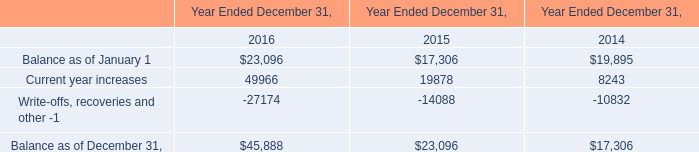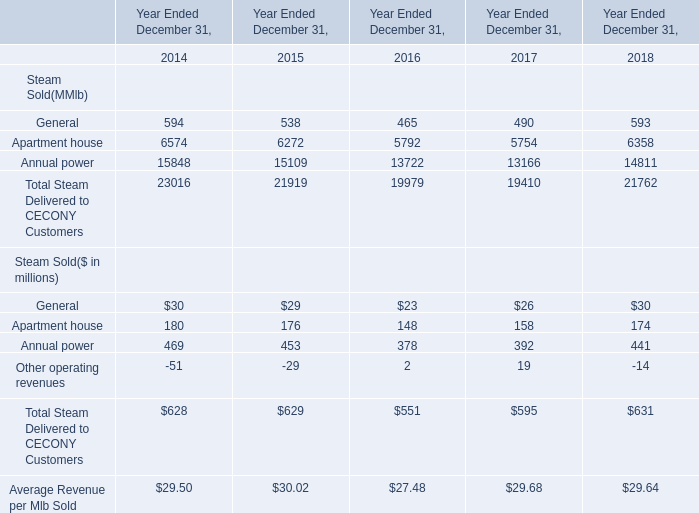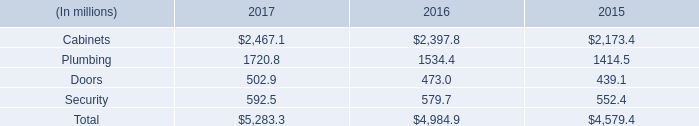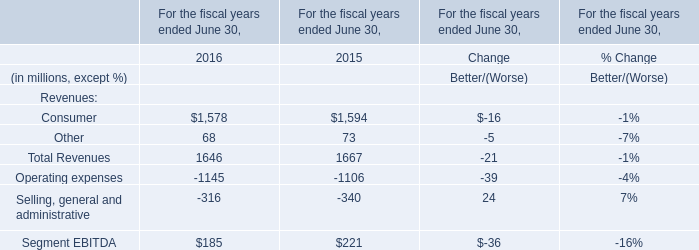What was the total amount of Steam Delivered to CECONY Customers in 2014？ (in million) 
Computations: ((594 + 6574) + 15848)
Answer: 23016.0. 